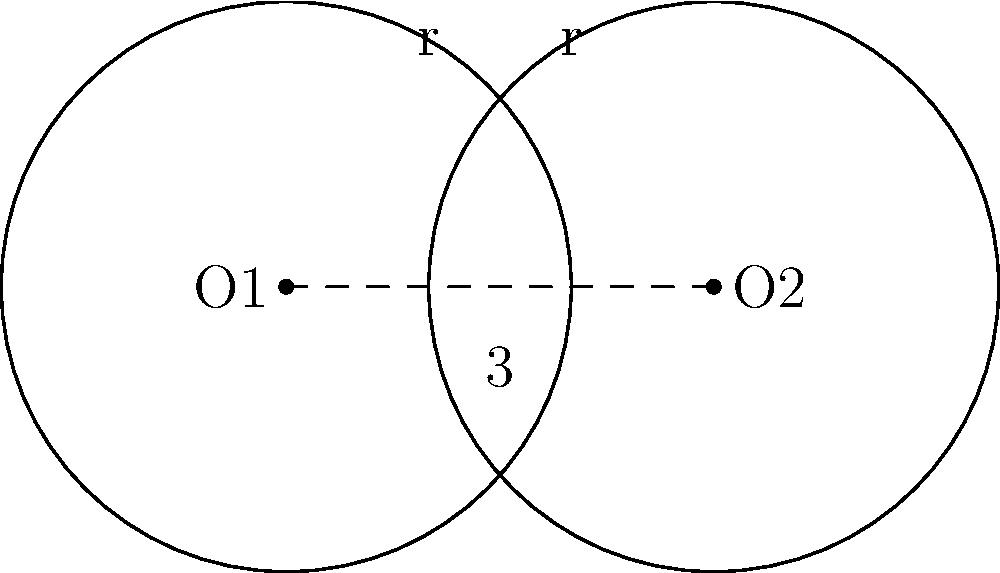In a laboratory experiment, two circular Petri dishes, each with a radius of 2 cm, are partially overlapping. The centers of the dishes are 3 cm apart. Calculate the area of the overlapping region between the two Petri dishes. Round your answer to two decimal places. To solve this problem, we'll use the formula for the area of overlap between two circles:

1) First, we need to find the angle θ (in radians) at the center of each circle:
   $$\theta = 2 \arccos(\frac{d}{2r})$$
   where d is the distance between centers and r is the radius.

2) Substitute the values:
   $$\theta = 2 \arccos(\frac{3}{2(2)}) = 2 \arccos(0.75) \approx 1.5708$$

3) Now, we can use the formula for the area of overlap:
   $$A = 2r^2 \arccos(\frac{d}{2r}) - d\sqrt{r^2 - (\frac{d}{2})^2}$$

4) Substitute the values:
   $$A = 2(2^2) \arccos(\frac{3}{2(2)}) - 3\sqrt{2^2 - (\frac{3}{2})^2}$$

5) Simplify:
   $$A = 8 \arccos(0.75) - 3\sqrt{4 - 2.25}$$
   $$A = 8(0.7854) - 3\sqrt{1.75}$$
   $$A = 6.2832 - 3(1.3229)$$
   $$A = 6.2832 - 3.9687$$
   $$A \approx 2.3145$$

6) Rounding to two decimal places:
   $$A \approx 2.31 \text{ cm}^2$$
Answer: 2.31 cm² 